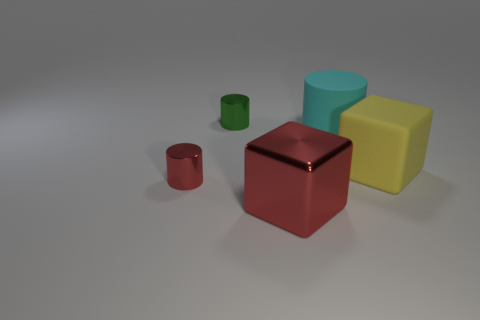Is there anything else that is the same size as the red cube?
Give a very brief answer. Yes. Is there anything else that is the same color as the big metallic cube?
Give a very brief answer. Yes. What number of blue things are either metal cubes or tiny objects?
Offer a very short reply. 0. Are there more large cyan objects than large red cylinders?
Your answer should be very brief. Yes. Does the rubber thing in front of the big rubber cylinder have the same size as the cylinder that is on the right side of the metal block?
Make the answer very short. Yes. There is a tiny cylinder that is in front of the small cylinder behind the yellow cube behind the red block; what is its color?
Provide a short and direct response. Red. Is there a red object of the same shape as the green metallic thing?
Keep it short and to the point. Yes. Is the number of cylinders behind the small red shiny cylinder greater than the number of green shiny cylinders?
Offer a very short reply. Yes. What number of metallic things are either cylinders or yellow objects?
Give a very brief answer. 2. There is a cylinder that is both to the left of the large rubber cylinder and to the right of the small red shiny cylinder; what is its size?
Give a very brief answer. Small. 